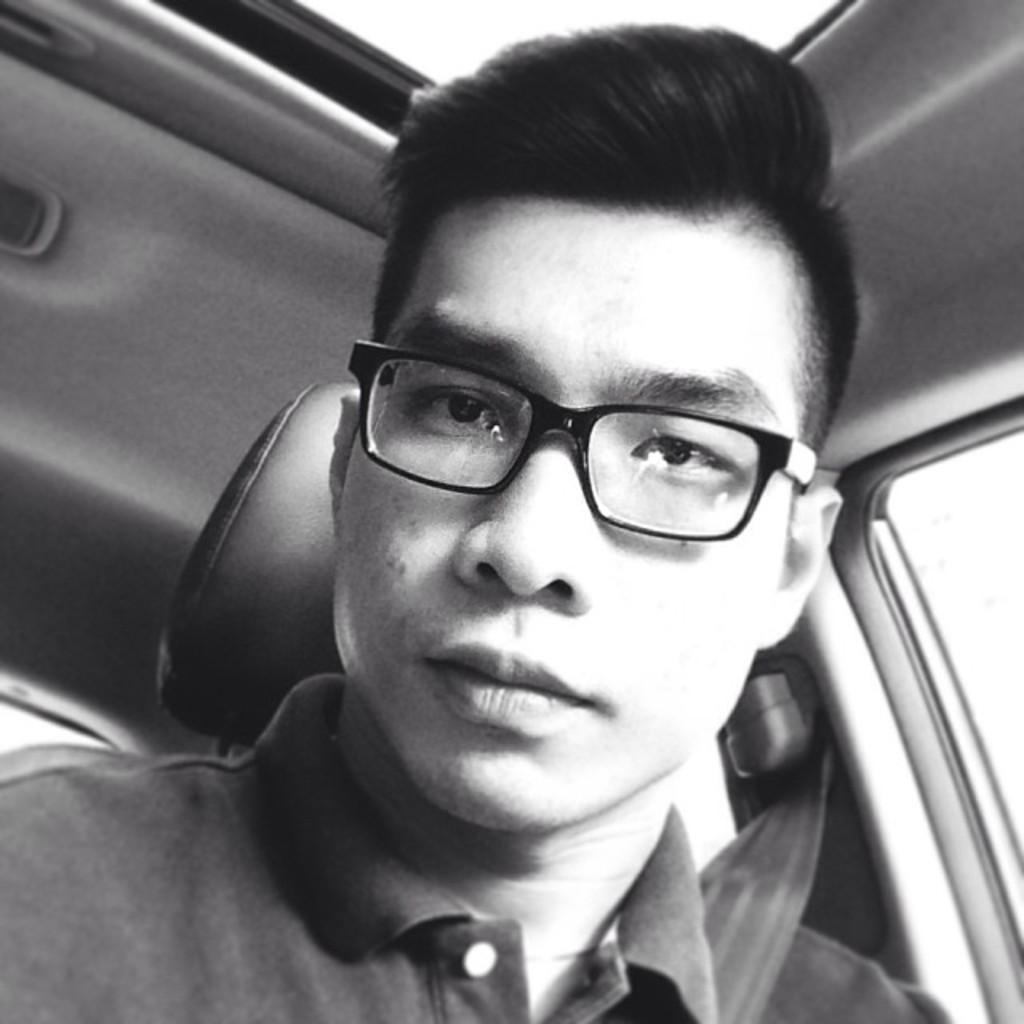Please provide a concise description of this image. In this image there is a person in the vehicle. 